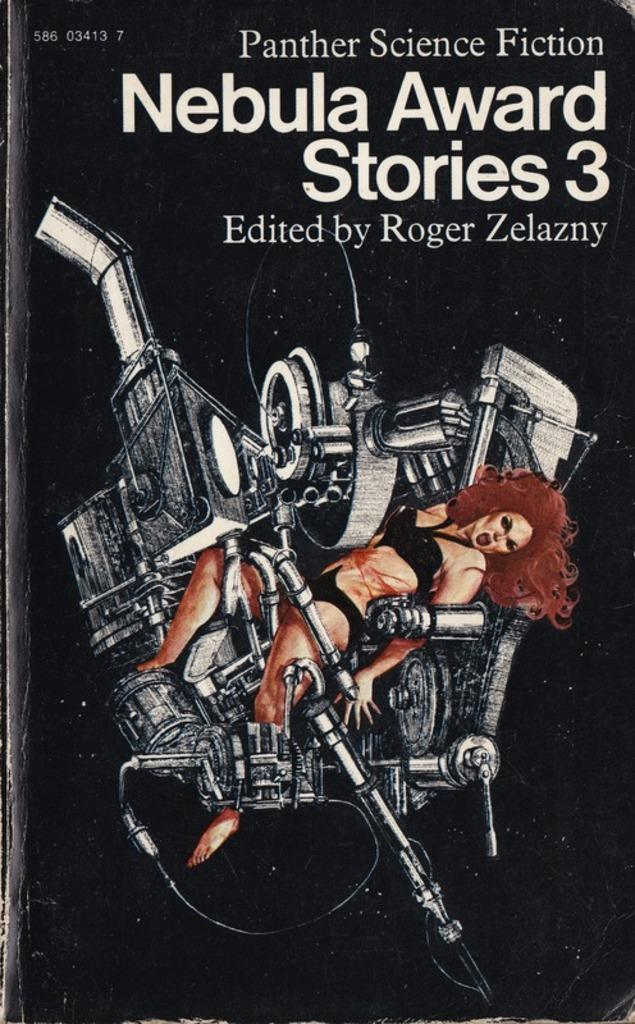<image>
Create a compact narrative representing the image presented. Third series of the Panther Science fiction Nebula Award Stories. 